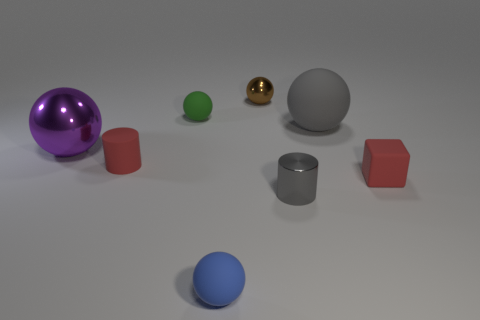Subtract all tiny brown spheres. How many spheres are left? 4 Subtract all green balls. How many balls are left? 4 Subtract all cyan balls. Subtract all yellow cylinders. How many balls are left? 5 Add 2 large green metallic cylinders. How many objects exist? 10 Subtract all cylinders. How many objects are left? 6 Add 6 small brown cylinders. How many small brown cylinders exist? 6 Subtract 0 purple cylinders. How many objects are left? 8 Subtract all large green spheres. Subtract all green things. How many objects are left? 7 Add 8 blue rubber balls. How many blue rubber balls are left? 9 